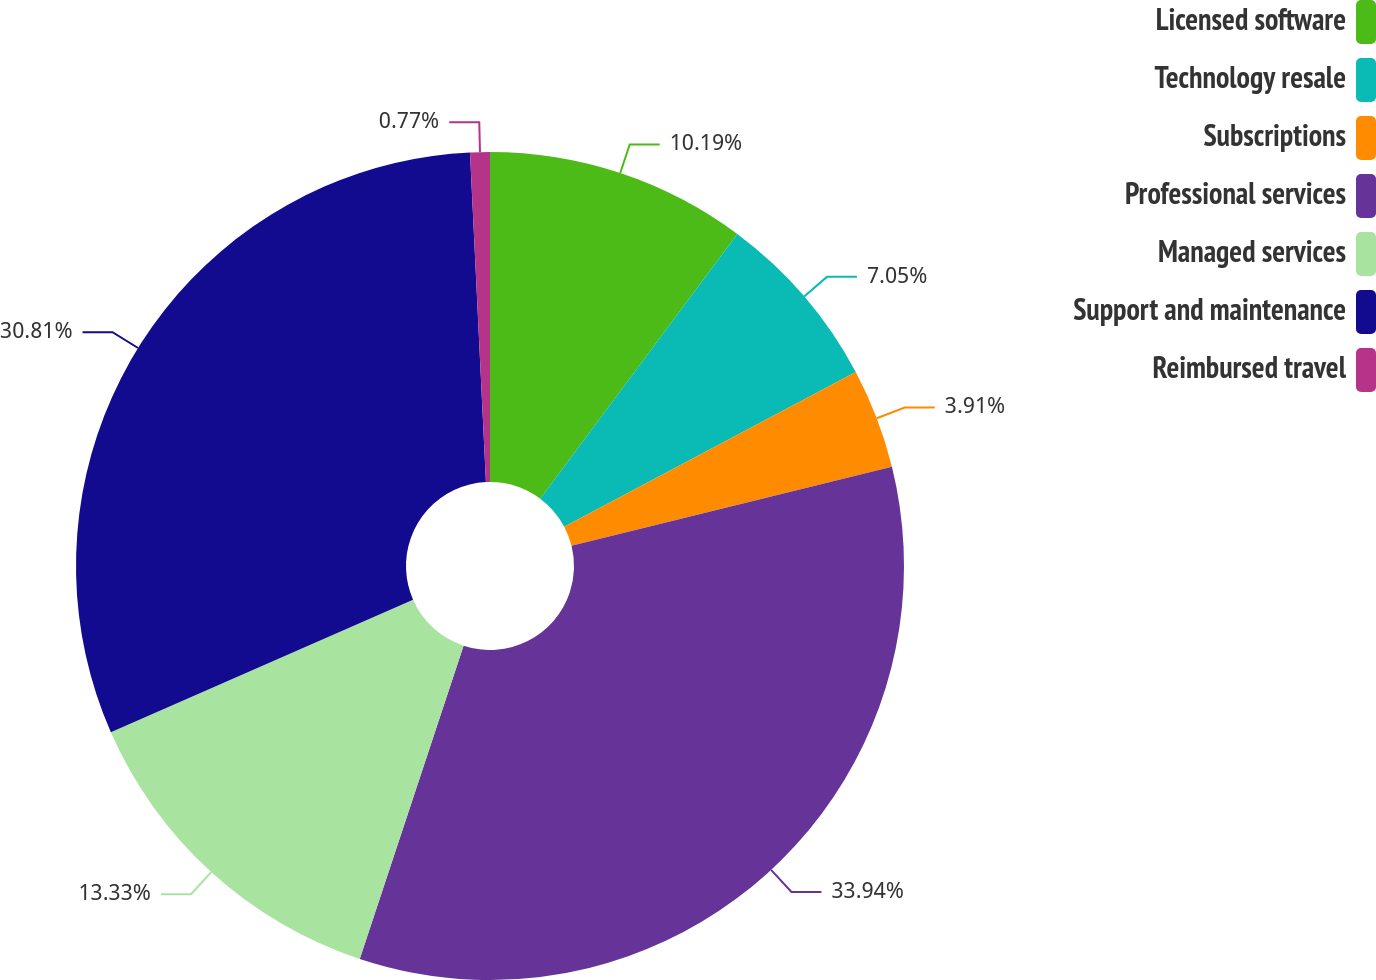Convert chart to OTSL. <chart><loc_0><loc_0><loc_500><loc_500><pie_chart><fcel>Licensed software<fcel>Technology resale<fcel>Subscriptions<fcel>Professional services<fcel>Managed services<fcel>Support and maintenance<fcel>Reimbursed travel<nl><fcel>10.19%<fcel>7.05%<fcel>3.91%<fcel>33.95%<fcel>13.33%<fcel>30.81%<fcel>0.77%<nl></chart> 